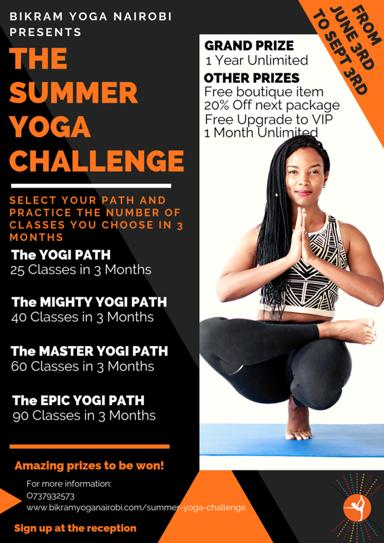Can you tell us more about the instructor featured in the image? While I can't provide personal details about the instructor, the image showcases a poised and confident yoga practitioner, likely representing the high level of expertise and welcoming atmosphere participants can expect at Bikram Yoga Nairobi during the Summer Yoga Challenge. 